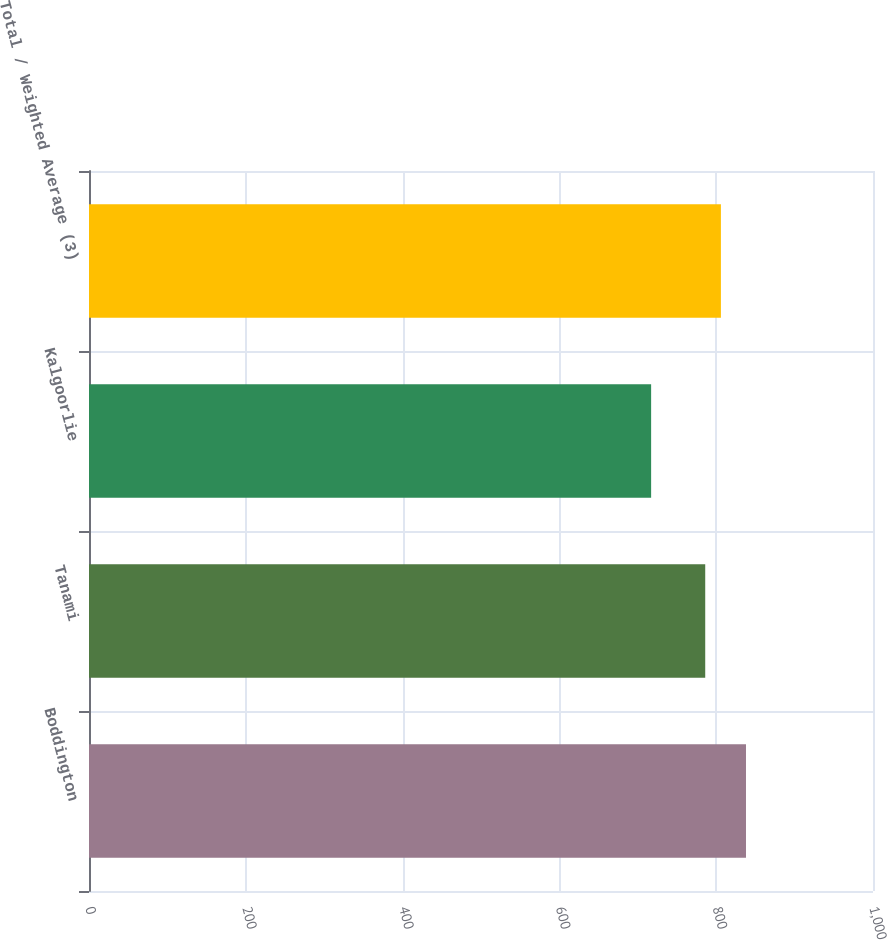<chart> <loc_0><loc_0><loc_500><loc_500><bar_chart><fcel>Boddington<fcel>Tanami<fcel>Kalgoorlie<fcel>Total / Weighted Average (3)<nl><fcel>838<fcel>786<fcel>717<fcel>806<nl></chart> 